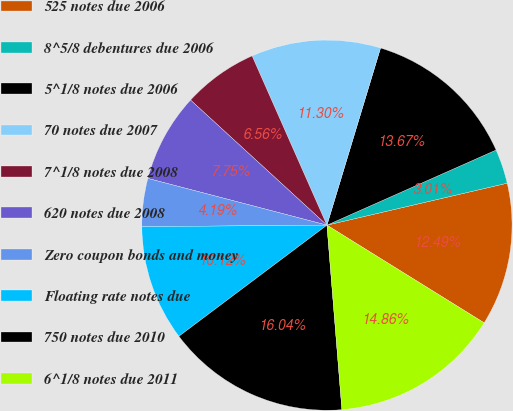Convert chart to OTSL. <chart><loc_0><loc_0><loc_500><loc_500><pie_chart><fcel>525 notes due 2006<fcel>8^5/8 debentures due 2006<fcel>5^1/8 notes due 2006<fcel>70 notes due 2007<fcel>7^1/8 notes due 2008<fcel>620 notes due 2008<fcel>Zero coupon bonds and money<fcel>Floating rate notes due<fcel>750 notes due 2010<fcel>6^1/8 notes due 2011<nl><fcel>12.49%<fcel>3.01%<fcel>13.67%<fcel>11.3%<fcel>6.56%<fcel>7.75%<fcel>4.19%<fcel>10.12%<fcel>16.04%<fcel>14.86%<nl></chart> 